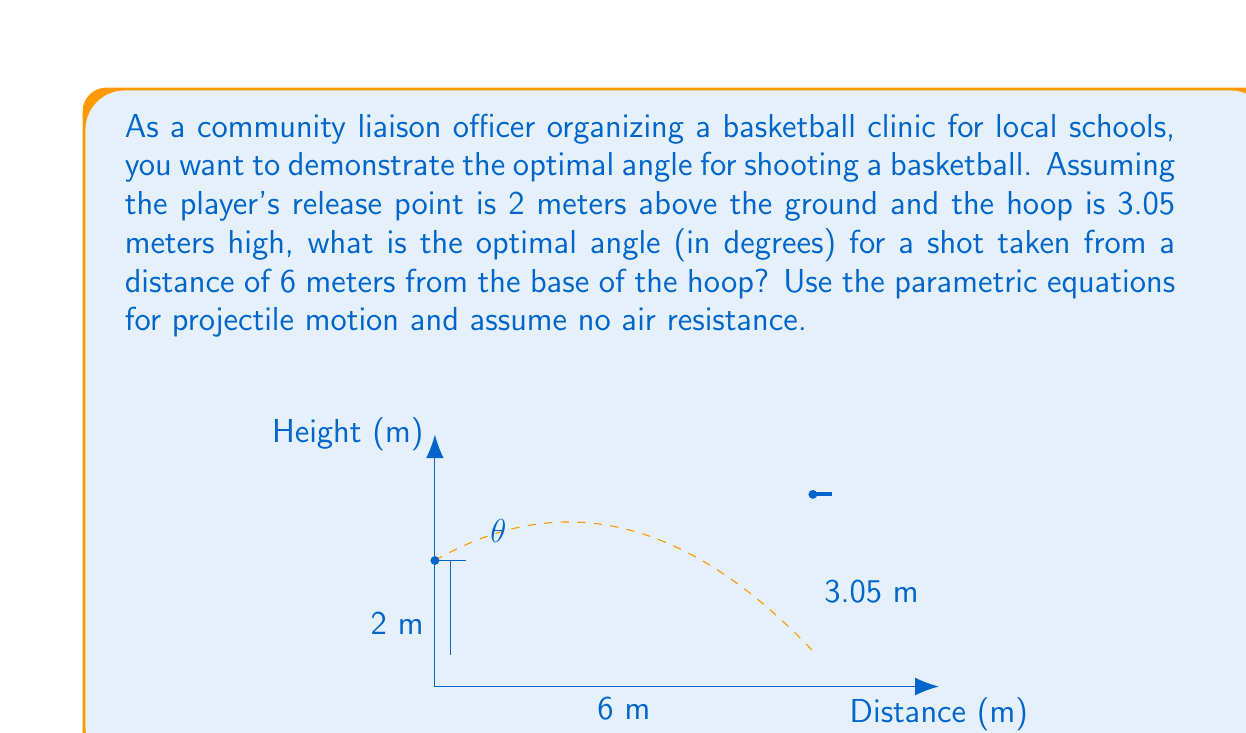Solve this math problem. To find the optimal angle for a basketball shot, we need to use the parametric equations for projectile motion and optimize for the angle that requires the least initial velocity.

1) The parametric equations for projectile motion are:

   $$x = v_0 \cos(\theta) t$$
   $$y = -\frac{1}{2}gt^2 + v_0 \sin(\theta) t + h_0$$

   Where $v_0$ is the initial velocity, $\theta$ is the launch angle, $g$ is the acceleration due to gravity (9.8 m/s²), $t$ is time, and $h_0$ is the initial height.

2) We know that at the final position, $x = 6$ m and $y = 3.05$ m. The initial height $h_0 = 2$ m.

3) Using the x-equation, we can express time in terms of other variables:

   $$t = \frac{6}{v_0 \cos(\theta)}$$

4) Substituting this into the y-equation:

   $$3.05 = -\frac{1}{2}g(\frac{6}{v_0 \cos(\theta)})^2 + v_0 \sin(\theta) \frac{6}{v_0 \cos(\theta)} + 2$$

5) Simplifying:

   $$1.05 = -\frac{18g}{v_0^2 \cos^2(\theta)} + 6 \tan(\theta)$$

6) Rearranging to express $v_0$ in terms of $\theta$:

   $$v_0^2 = \frac{18g}{6 \tan(\theta) - 1.05} \sec^2(\theta)$$

7) The optimal angle is the one that minimizes $v_0$. We can find this by differentiating $v_0^2$ with respect to $\theta$ and setting it to zero. However, this leads to a complex equation.

8) A good approximation for the optimal angle when the target is above the launch point is:

   $$\theta_{opt} \approx 45° + \frac{1}{2}\arctan(\frac{h}{d})$$

   Where $h$ is the height difference (1.05 m) and $d$ is the horizontal distance (6 m).

9) Calculating:

   $$\theta_{opt} \approx 45° + \frac{1}{2}\arctan(\frac{1.05}{6}) \approx 49.95°$$

This angle provides the optimal balance between the horizontal distance needed to reach the hoop and the vertical displacement required to achieve the correct height.
Answer: The optimal angle for the basketball shot is approximately 49.95°. 